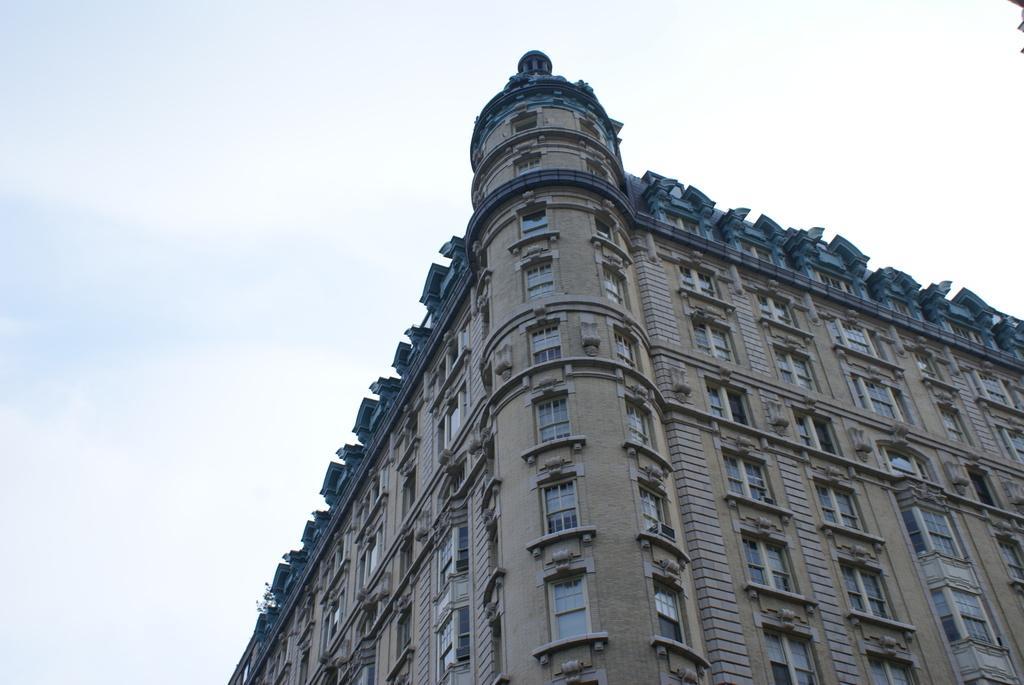Can you describe this image briefly? In this image I can see a building, number of windows and in background I can see the sky. 